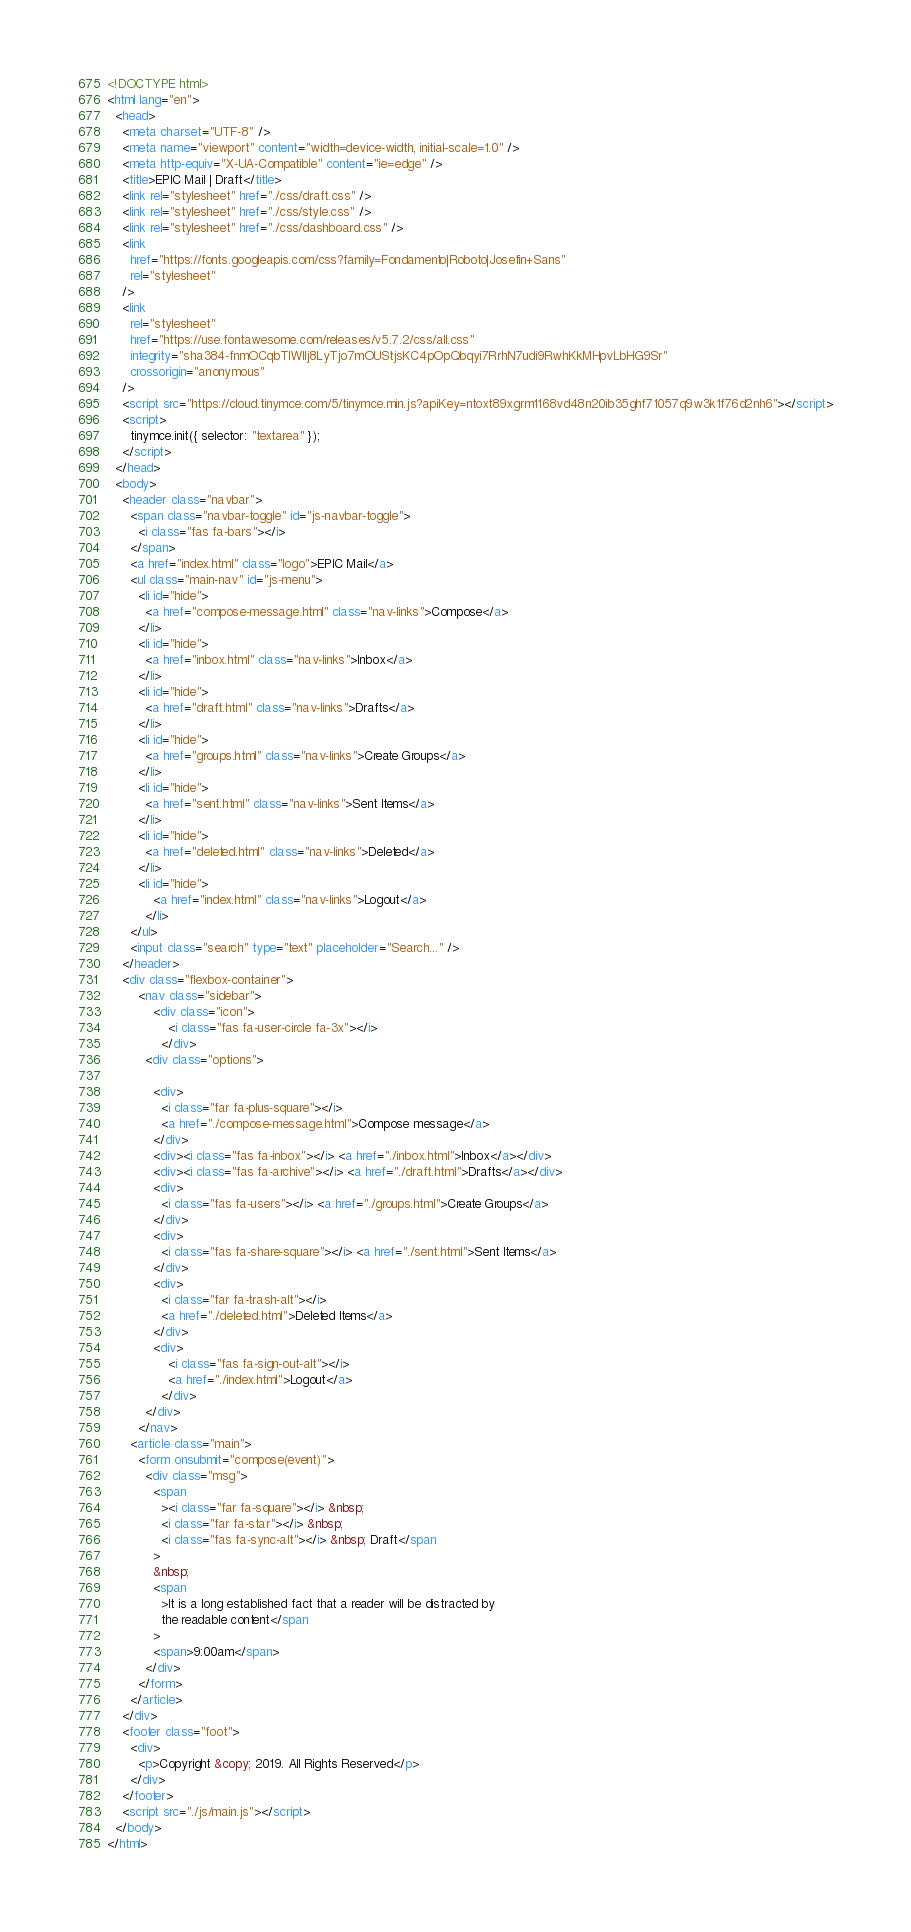<code> <loc_0><loc_0><loc_500><loc_500><_HTML_><!DOCTYPE html>
<html lang="en">
  <head>
    <meta charset="UTF-8" />
    <meta name="viewport" content="width=device-width, initial-scale=1.0" />
    <meta http-equiv="X-UA-Compatible" content="ie=edge" />
    <title>EPIC Mail | Draft</title>
    <link rel="stylesheet" href="./css/draft.css" />
    <link rel="stylesheet" href="./css/style.css" />
    <link rel="stylesheet" href="./css/dashboard.css" />
    <link
      href="https://fonts.googleapis.com/css?family=Fondamento|Roboto|Josefin+Sans"
      rel="stylesheet"
    />
    <link
      rel="stylesheet"
      href="https://use.fontawesome.com/releases/v5.7.2/css/all.css"
      integrity="sha384-fnmOCqbTlWIlj8LyTjo7mOUStjsKC4pOpQbqyi7RrhN7udi9RwhKkMHpvLbHG9Sr"
      crossorigin="anonymous"
    />
    <script src="https://cloud.tinymce.com/5/tinymce.min.js?apiKey=ntoxt89xgrm1168vd48n20ib35ghf71057q9w3k1f76d2nh6"></script>
    <script>
      tinymce.init({ selector: "textarea" });
    </script>
  </head>
  <body>
    <header class="navbar">
      <span class="navbar-toggle" id="js-navbar-toggle">
        <i class="fas fa-bars"></i>
      </span>
      <a href="index.html" class="logo">EPIC Mail</a>
      <ul class="main-nav" id="js-menu">
        <li id="hide">
          <a href="compose-message.html" class="nav-links">Compose</a>
        </li>
        <li id="hide">
          <a href="inbox.html" class="nav-links">Inbox</a>
        </li>
        <li id="hide">
          <a href="draft.html" class="nav-links">Drafts</a>
        </li>
        <li id="hide">
          <a href="groups.html" class="nav-links">Create Groups</a>
        </li>
        <li id="hide">
          <a href="sent.html" class="nav-links">Sent Items</a>
        </li>
        <li id="hide">
          <a href="deleted.html" class="nav-links">Deleted</a>
        </li>
        <li id="hide">
            <a href="index.html" class="nav-links">Logout</a>
          </li>
      </ul>
      <input class="search" type="text" placeholder="Search..." />
    </header>
    <div class="flexbox-container">
        <nav class="sidebar">
            <div class="icon">
                <i class="fas fa-user-circle fa-3x"></i>
              </div>
          <div class="options">
            
            <div>
              <i class="far fa-plus-square"></i>
              <a href="./compose-message.html">Compose message</a>
            </div>
            <div><i class="fas fa-inbox"></i> <a href="./inbox.html">Inbox</a></div>
            <div><i class="fas fa-archive"></i> <a href="./draft.html">Drafts</a></div>
            <div>
              <i class="fas fa-users"></i> <a href="./groups.html">Create Groups</a>
            </div>
            <div>
              <i class="fas fa-share-square"></i> <a href="./sent.html">Sent Items</a>
            </div>
            <div>
              <i class="far fa-trash-alt"></i>
              <a href="./deleted.html">Deleted Items</a>
            </div>
            <div>
                <i class="fas fa-sign-out-alt"></i>
                <a href="./index.html">Logout</a>
              </div>
          </div>
        </nav>
      <article class="main">
        <form onsubmit="compose(event)">
          <div class="msg">
            <span
              ><i class="far fa-square"></i> &nbsp;
              <i class="far fa-star"></i> &nbsp;
              <i class="fas fa-sync-alt"></i> &nbsp; Draft</span
            >
            &nbsp;
            <span
              >It is a long established fact that a reader will be distracted by
              the readable content</span
            >
            <span>9:00am</span>
          </div>
        </form>
      </article>
    </div>
    <footer class="foot">
      <div>
        <p>Copyright &copy; 2019. All Rights Reserved</p>
      </div>
    </footer>
    <script src="./js/main.js"></script>
  </body>
</html>
</code> 